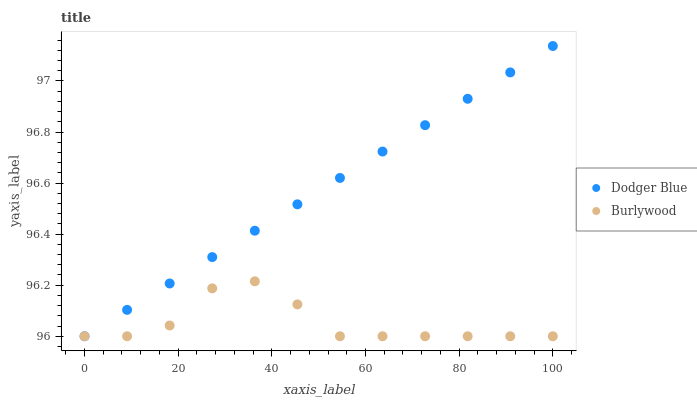Does Burlywood have the minimum area under the curve?
Answer yes or no. Yes. Does Dodger Blue have the maximum area under the curve?
Answer yes or no. Yes. Does Dodger Blue have the minimum area under the curve?
Answer yes or no. No. Is Dodger Blue the smoothest?
Answer yes or no. Yes. Is Burlywood the roughest?
Answer yes or no. Yes. Is Dodger Blue the roughest?
Answer yes or no. No. Does Burlywood have the lowest value?
Answer yes or no. Yes. Does Dodger Blue have the highest value?
Answer yes or no. Yes. Does Dodger Blue intersect Burlywood?
Answer yes or no. Yes. Is Dodger Blue less than Burlywood?
Answer yes or no. No. Is Dodger Blue greater than Burlywood?
Answer yes or no. No. 